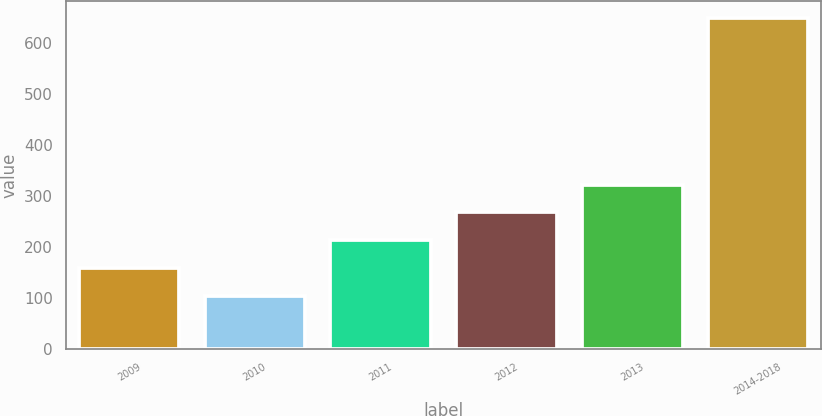Convert chart to OTSL. <chart><loc_0><loc_0><loc_500><loc_500><bar_chart><fcel>2009<fcel>2010<fcel>2011<fcel>2012<fcel>2013<fcel>2014-2018<nl><fcel>158.6<fcel>104<fcel>213.2<fcel>267.8<fcel>322.4<fcel>650<nl></chart> 